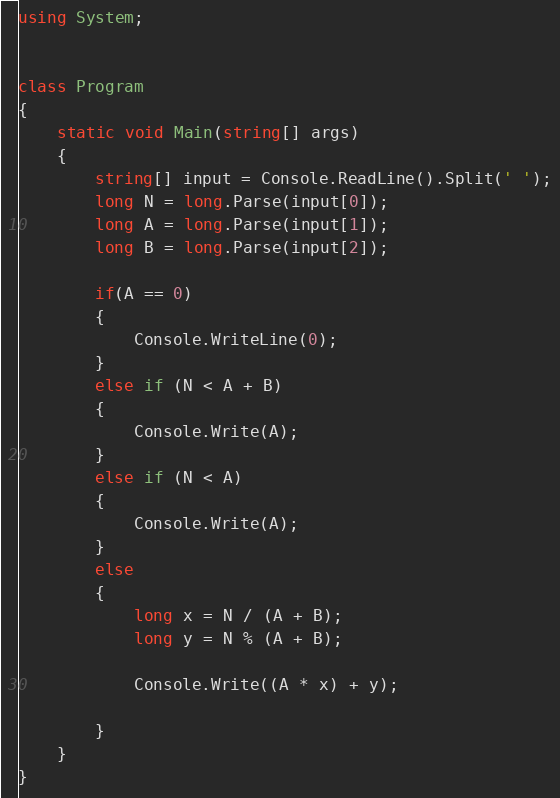<code> <loc_0><loc_0><loc_500><loc_500><_C#_>using System;


class Program
{
    static void Main(string[] args)
    {
        string[] input = Console.ReadLine().Split(' ');
        long N = long.Parse(input[0]);
        long A = long.Parse(input[1]);
        long B = long.Parse(input[2]);

        if(A == 0)
        {
            Console.WriteLine(0);
        }
        else if (N < A + B)
        {
            Console.Write(A);
        }
        else if (N < A)
        {
            Console.Write(A);
        }
        else
        {
            long x = N / (A + B);
            long y = N % (A + B);

            Console.Write((A * x) + y);
            
        }
    }
}</code> 